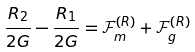Convert formula to latex. <formula><loc_0><loc_0><loc_500><loc_500>\frac { R _ { 2 } } { 2 G } - \frac { R _ { 1 } } { 2 G } = \mathcal { F } ^ { ( R ) } _ { m } + \mathcal { F } ^ { ( R ) } _ { g }</formula> 